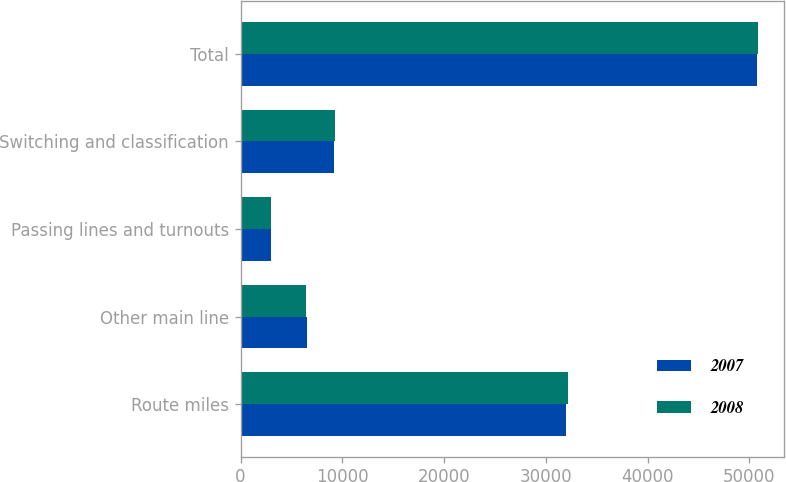Convert chart to OTSL. <chart><loc_0><loc_0><loc_500><loc_500><stacked_bar_chart><ecel><fcel>Route miles<fcel>Other main line<fcel>Passing lines and turnouts<fcel>Switching and classification<fcel>Total<nl><fcel>2007<fcel>32012<fcel>6510<fcel>3037<fcel>9207<fcel>50766<nl><fcel>2008<fcel>32205<fcel>6404<fcel>3021<fcel>9270<fcel>50900<nl></chart> 